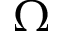<formula> <loc_0><loc_0><loc_500><loc_500>\Omega</formula> 